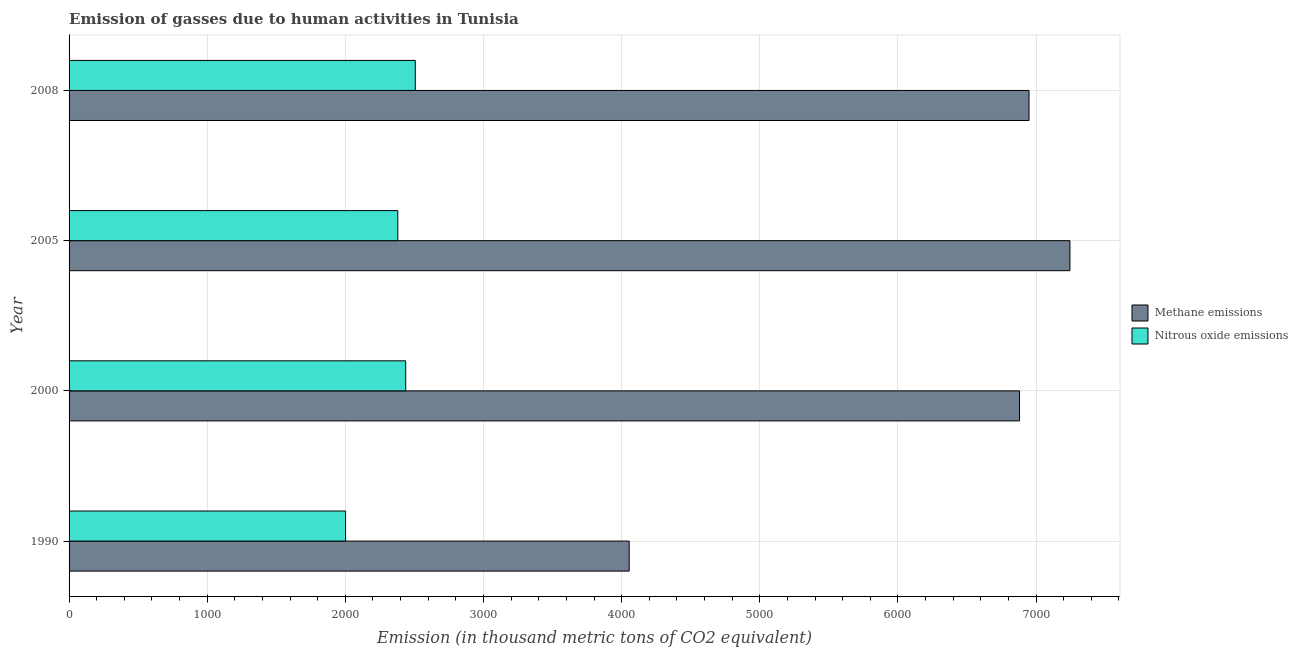How many bars are there on the 4th tick from the bottom?
Provide a succinct answer. 2. What is the label of the 1st group of bars from the top?
Make the answer very short. 2008. What is the amount of nitrous oxide emissions in 2005?
Ensure brevity in your answer.  2379.7. Across all years, what is the maximum amount of nitrous oxide emissions?
Give a very brief answer. 2506.4. Across all years, what is the minimum amount of methane emissions?
Keep it short and to the point. 4054.8. In which year was the amount of nitrous oxide emissions maximum?
Provide a short and direct response. 2008. What is the total amount of methane emissions in the graph?
Offer a very short reply. 2.51e+04. What is the difference between the amount of nitrous oxide emissions in 2005 and that in 2008?
Make the answer very short. -126.7. What is the difference between the amount of methane emissions in 2000 and the amount of nitrous oxide emissions in 2005?
Keep it short and to the point. 4500.9. What is the average amount of nitrous oxide emissions per year?
Make the answer very short. 2331.18. In the year 2000, what is the difference between the amount of nitrous oxide emissions and amount of methane emissions?
Your response must be concise. -4443.7. What is the ratio of the amount of methane emissions in 1990 to that in 2000?
Offer a very short reply. 0.59. Is the amount of methane emissions in 2005 less than that in 2008?
Keep it short and to the point. No. What is the difference between the highest and the second highest amount of nitrous oxide emissions?
Ensure brevity in your answer.  69.5. What is the difference between the highest and the lowest amount of nitrous oxide emissions?
Offer a terse response. 504.7. In how many years, is the amount of nitrous oxide emissions greater than the average amount of nitrous oxide emissions taken over all years?
Your response must be concise. 3. What does the 1st bar from the top in 2005 represents?
Give a very brief answer. Nitrous oxide emissions. What does the 1st bar from the bottom in 1990 represents?
Give a very brief answer. Methane emissions. What is the difference between two consecutive major ticks on the X-axis?
Your answer should be compact. 1000. How many legend labels are there?
Provide a short and direct response. 2. How are the legend labels stacked?
Your answer should be compact. Vertical. What is the title of the graph?
Offer a very short reply. Emission of gasses due to human activities in Tunisia. What is the label or title of the X-axis?
Keep it short and to the point. Emission (in thousand metric tons of CO2 equivalent). What is the label or title of the Y-axis?
Give a very brief answer. Year. What is the Emission (in thousand metric tons of CO2 equivalent) of Methane emissions in 1990?
Offer a terse response. 4054.8. What is the Emission (in thousand metric tons of CO2 equivalent) in Nitrous oxide emissions in 1990?
Make the answer very short. 2001.7. What is the Emission (in thousand metric tons of CO2 equivalent) in Methane emissions in 2000?
Offer a terse response. 6880.6. What is the Emission (in thousand metric tons of CO2 equivalent) of Nitrous oxide emissions in 2000?
Provide a short and direct response. 2436.9. What is the Emission (in thousand metric tons of CO2 equivalent) of Methane emissions in 2005?
Give a very brief answer. 7245.4. What is the Emission (in thousand metric tons of CO2 equivalent) in Nitrous oxide emissions in 2005?
Make the answer very short. 2379.7. What is the Emission (in thousand metric tons of CO2 equivalent) in Methane emissions in 2008?
Your response must be concise. 6949.3. What is the Emission (in thousand metric tons of CO2 equivalent) in Nitrous oxide emissions in 2008?
Your answer should be very brief. 2506.4. Across all years, what is the maximum Emission (in thousand metric tons of CO2 equivalent) in Methane emissions?
Offer a terse response. 7245.4. Across all years, what is the maximum Emission (in thousand metric tons of CO2 equivalent) of Nitrous oxide emissions?
Your response must be concise. 2506.4. Across all years, what is the minimum Emission (in thousand metric tons of CO2 equivalent) in Methane emissions?
Provide a short and direct response. 4054.8. Across all years, what is the minimum Emission (in thousand metric tons of CO2 equivalent) of Nitrous oxide emissions?
Offer a very short reply. 2001.7. What is the total Emission (in thousand metric tons of CO2 equivalent) of Methane emissions in the graph?
Provide a succinct answer. 2.51e+04. What is the total Emission (in thousand metric tons of CO2 equivalent) in Nitrous oxide emissions in the graph?
Make the answer very short. 9324.7. What is the difference between the Emission (in thousand metric tons of CO2 equivalent) in Methane emissions in 1990 and that in 2000?
Your answer should be very brief. -2825.8. What is the difference between the Emission (in thousand metric tons of CO2 equivalent) in Nitrous oxide emissions in 1990 and that in 2000?
Give a very brief answer. -435.2. What is the difference between the Emission (in thousand metric tons of CO2 equivalent) of Methane emissions in 1990 and that in 2005?
Your response must be concise. -3190.6. What is the difference between the Emission (in thousand metric tons of CO2 equivalent) of Nitrous oxide emissions in 1990 and that in 2005?
Your response must be concise. -378. What is the difference between the Emission (in thousand metric tons of CO2 equivalent) of Methane emissions in 1990 and that in 2008?
Offer a very short reply. -2894.5. What is the difference between the Emission (in thousand metric tons of CO2 equivalent) in Nitrous oxide emissions in 1990 and that in 2008?
Your answer should be compact. -504.7. What is the difference between the Emission (in thousand metric tons of CO2 equivalent) in Methane emissions in 2000 and that in 2005?
Provide a succinct answer. -364.8. What is the difference between the Emission (in thousand metric tons of CO2 equivalent) in Nitrous oxide emissions in 2000 and that in 2005?
Make the answer very short. 57.2. What is the difference between the Emission (in thousand metric tons of CO2 equivalent) of Methane emissions in 2000 and that in 2008?
Your answer should be compact. -68.7. What is the difference between the Emission (in thousand metric tons of CO2 equivalent) in Nitrous oxide emissions in 2000 and that in 2008?
Provide a short and direct response. -69.5. What is the difference between the Emission (in thousand metric tons of CO2 equivalent) of Methane emissions in 2005 and that in 2008?
Your response must be concise. 296.1. What is the difference between the Emission (in thousand metric tons of CO2 equivalent) in Nitrous oxide emissions in 2005 and that in 2008?
Keep it short and to the point. -126.7. What is the difference between the Emission (in thousand metric tons of CO2 equivalent) of Methane emissions in 1990 and the Emission (in thousand metric tons of CO2 equivalent) of Nitrous oxide emissions in 2000?
Your answer should be compact. 1617.9. What is the difference between the Emission (in thousand metric tons of CO2 equivalent) in Methane emissions in 1990 and the Emission (in thousand metric tons of CO2 equivalent) in Nitrous oxide emissions in 2005?
Give a very brief answer. 1675.1. What is the difference between the Emission (in thousand metric tons of CO2 equivalent) of Methane emissions in 1990 and the Emission (in thousand metric tons of CO2 equivalent) of Nitrous oxide emissions in 2008?
Offer a very short reply. 1548.4. What is the difference between the Emission (in thousand metric tons of CO2 equivalent) in Methane emissions in 2000 and the Emission (in thousand metric tons of CO2 equivalent) in Nitrous oxide emissions in 2005?
Keep it short and to the point. 4500.9. What is the difference between the Emission (in thousand metric tons of CO2 equivalent) of Methane emissions in 2000 and the Emission (in thousand metric tons of CO2 equivalent) of Nitrous oxide emissions in 2008?
Provide a short and direct response. 4374.2. What is the difference between the Emission (in thousand metric tons of CO2 equivalent) of Methane emissions in 2005 and the Emission (in thousand metric tons of CO2 equivalent) of Nitrous oxide emissions in 2008?
Make the answer very short. 4739. What is the average Emission (in thousand metric tons of CO2 equivalent) of Methane emissions per year?
Make the answer very short. 6282.52. What is the average Emission (in thousand metric tons of CO2 equivalent) in Nitrous oxide emissions per year?
Offer a very short reply. 2331.18. In the year 1990, what is the difference between the Emission (in thousand metric tons of CO2 equivalent) of Methane emissions and Emission (in thousand metric tons of CO2 equivalent) of Nitrous oxide emissions?
Offer a very short reply. 2053.1. In the year 2000, what is the difference between the Emission (in thousand metric tons of CO2 equivalent) of Methane emissions and Emission (in thousand metric tons of CO2 equivalent) of Nitrous oxide emissions?
Provide a short and direct response. 4443.7. In the year 2005, what is the difference between the Emission (in thousand metric tons of CO2 equivalent) of Methane emissions and Emission (in thousand metric tons of CO2 equivalent) of Nitrous oxide emissions?
Offer a very short reply. 4865.7. In the year 2008, what is the difference between the Emission (in thousand metric tons of CO2 equivalent) in Methane emissions and Emission (in thousand metric tons of CO2 equivalent) in Nitrous oxide emissions?
Offer a terse response. 4442.9. What is the ratio of the Emission (in thousand metric tons of CO2 equivalent) of Methane emissions in 1990 to that in 2000?
Your response must be concise. 0.59. What is the ratio of the Emission (in thousand metric tons of CO2 equivalent) in Nitrous oxide emissions in 1990 to that in 2000?
Ensure brevity in your answer.  0.82. What is the ratio of the Emission (in thousand metric tons of CO2 equivalent) of Methane emissions in 1990 to that in 2005?
Your answer should be compact. 0.56. What is the ratio of the Emission (in thousand metric tons of CO2 equivalent) of Nitrous oxide emissions in 1990 to that in 2005?
Provide a succinct answer. 0.84. What is the ratio of the Emission (in thousand metric tons of CO2 equivalent) of Methane emissions in 1990 to that in 2008?
Your answer should be compact. 0.58. What is the ratio of the Emission (in thousand metric tons of CO2 equivalent) of Nitrous oxide emissions in 1990 to that in 2008?
Make the answer very short. 0.8. What is the ratio of the Emission (in thousand metric tons of CO2 equivalent) of Methane emissions in 2000 to that in 2005?
Ensure brevity in your answer.  0.95. What is the ratio of the Emission (in thousand metric tons of CO2 equivalent) in Nitrous oxide emissions in 2000 to that in 2008?
Offer a very short reply. 0.97. What is the ratio of the Emission (in thousand metric tons of CO2 equivalent) in Methane emissions in 2005 to that in 2008?
Give a very brief answer. 1.04. What is the ratio of the Emission (in thousand metric tons of CO2 equivalent) of Nitrous oxide emissions in 2005 to that in 2008?
Your answer should be compact. 0.95. What is the difference between the highest and the second highest Emission (in thousand metric tons of CO2 equivalent) in Methane emissions?
Offer a very short reply. 296.1. What is the difference between the highest and the second highest Emission (in thousand metric tons of CO2 equivalent) of Nitrous oxide emissions?
Provide a succinct answer. 69.5. What is the difference between the highest and the lowest Emission (in thousand metric tons of CO2 equivalent) in Methane emissions?
Ensure brevity in your answer.  3190.6. What is the difference between the highest and the lowest Emission (in thousand metric tons of CO2 equivalent) of Nitrous oxide emissions?
Give a very brief answer. 504.7. 